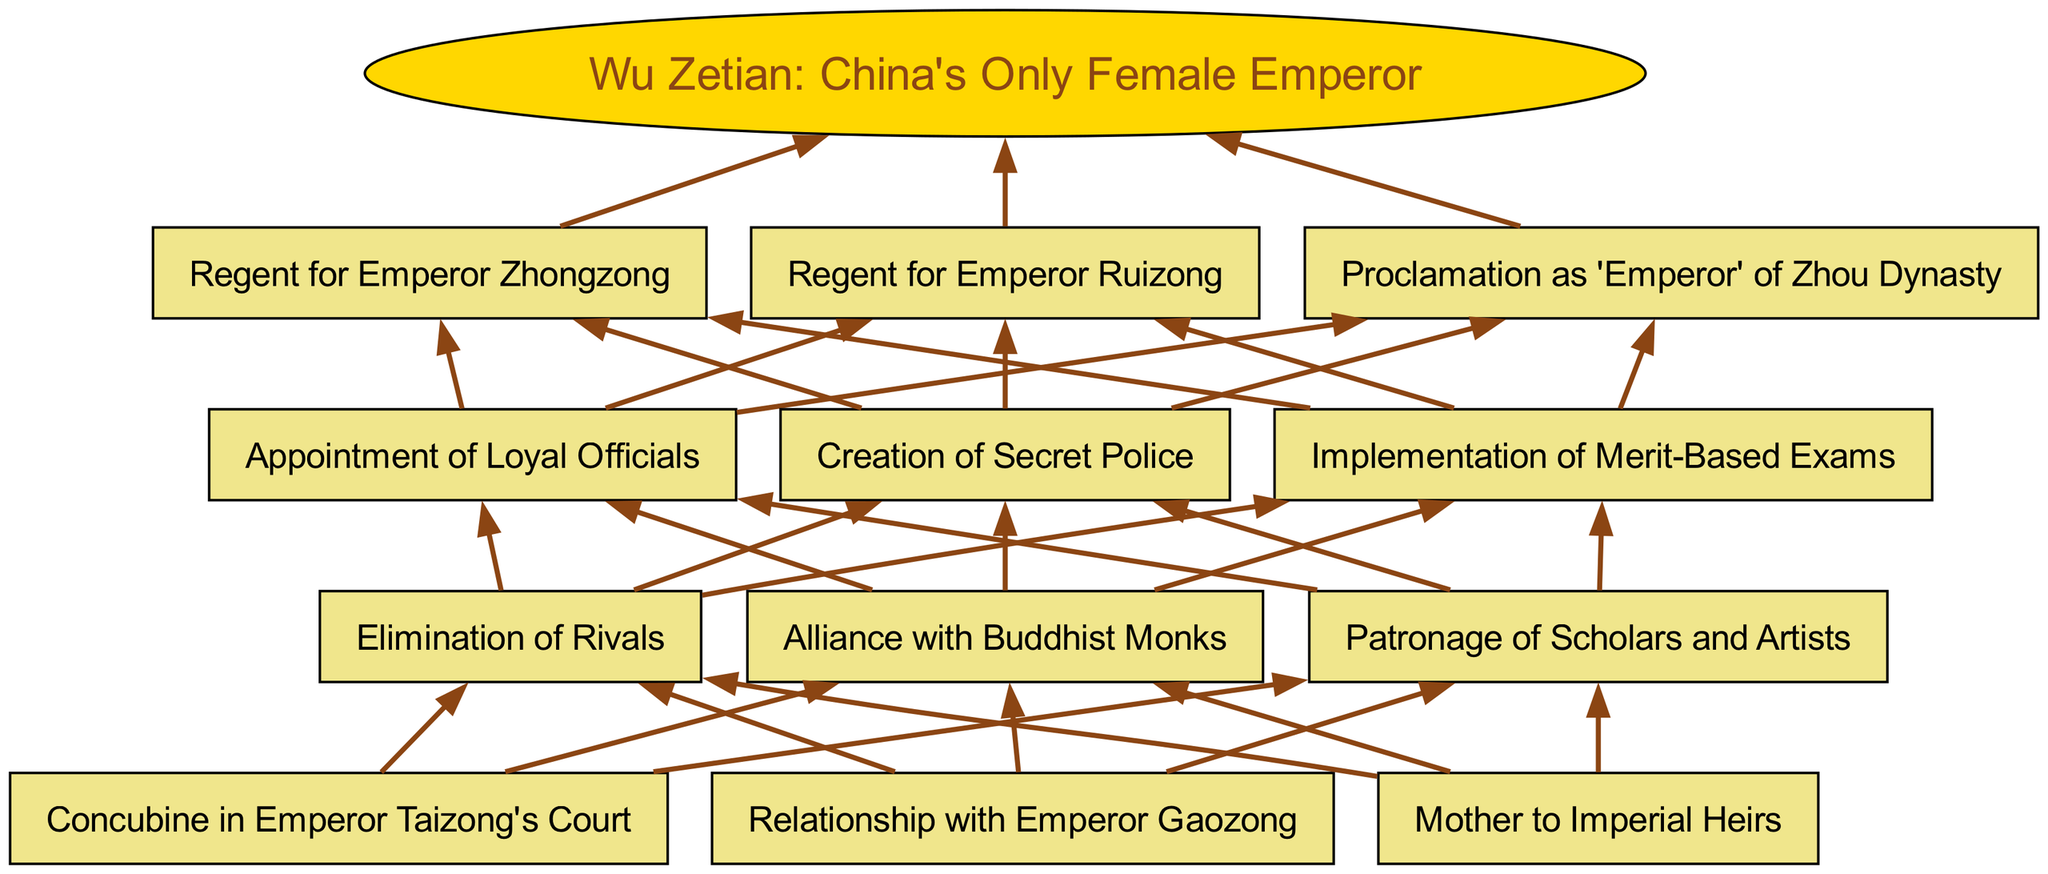What is the root node of the diagram? The root node, representing the central theme of the diagram, is "Wu Zetian: China's Only Female Emperor."
Answer: Wu Zetian: China's Only Female Emperor How many levels are in the diagram? The diagram consists of four levels. The levels are labeled from 1 to 4, indicating the hierarchy in Wu Zetian's political ascent.
Answer: 4 What was Wu Zetian's role in Emperor Taizong's court? Wu Zetian served as a "Concubine in Emperor Taizong's Court." This node is the first aspect of her initial position, highlighting her entry point into the imperial hierarchy.
Answer: Concubine in Emperor Taizong's Court What connections can be found at level 2? Level 2 includes three nodes: "Elimination of Rivals," "Alliance with Buddhist Monks," and "Patronage of Scholars and Artists." These nodes represent her methods of consolidating power.
Answer: Elimination of Rivals, Alliance with Buddhist Monks, Patronage of Scholars and Artists What actions did Wu Zetian take to ensure loyalty from officials? She appointed loyal officials, a specific strategy indicated in level 3. This action is part of her broader approach to maintain control and strengthen her power base.
Answer: Appointment of Loyal Officials How did Wu Zetian's title evolve in the last level? The final level shows her proclamation as "Emperor" of the Zhou Dynasty, which indicates her ultimate elevation to power after serving as regent for two emperors.
Answer: Proclamation as 'Emperor' of Zhou Dynasty What was the relationship between her regency and her title as Emperor? Wu Zetian served as regent for both Emperor Zhongzong and Emperor Ruizong, actions that facilitated her path to proclaiming herself as “Emperor” of the Zhou Dynasty. This illustrates her strategic maneuvering in securing her own authority.
Answer: Regent for Emperor Zhongzong, Regent for Emperor Ruizong, Proclamation as 'Emperor' of Zhou Dynasty What is the significance of the "Implementation of Merit-Based Exams"? This strategy reflects her efforts to recruit officials based on merit rather than favoritism. It is part of her level 3 strategies, showcasing her progressive governance and shifting political dynamics.
Answer: Implementation of Merit-Based Exams 